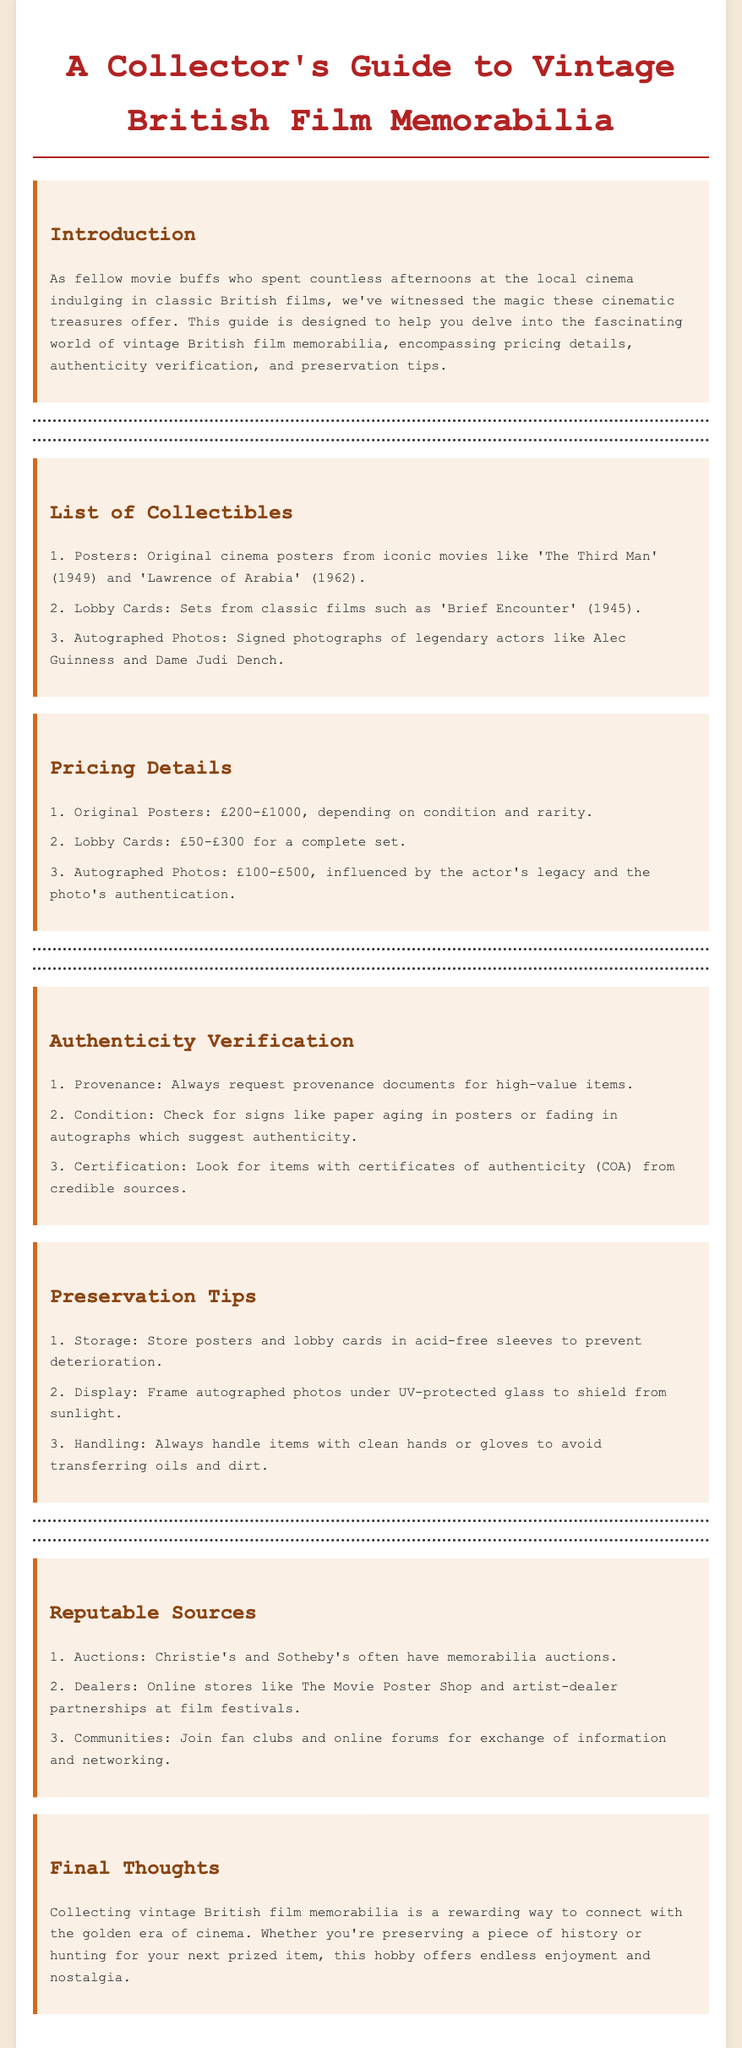What is the title of the guide? The title is stated prominently at the top of the document.
Answer: A Collector's Guide to Vintage British Film Memorabilia What are the three types of collectibles listed? The document explicitly lists three types of collectibles under the respective section.
Answer: Posters, Lobby Cards, Autographed Photos What is the price range for original posters? The pricing details for original posters are provided in the document.
Answer: £200-£1000 What should you check to verify authenticity? The document lists specific checks for authenticity verification in this section.
Answer: Provenance What is recommended for storing posters? The preservation tips suggest specific storage methods for items to protect them.
Answer: Acid-free sleeves Which auction houses are mentioned? The document references reputable sources for acquiring memorabilia, including specific auction houses.
Answer: Christie's and Sotheby's How should autographed photos be displayed? The preservation tips provide guidance on the best display methods for autographed items.
Answer: Under UV-protected glass What do authenticity certificates represent? The document defines the role of certificates in verifying authenticity of memorabilia.
Answer: Authenticity Name a dealer mentioned that sells memorabilia. The document lists several sources for memorabilia, including specific online stores.
Answer: The Movie Poster Shop 